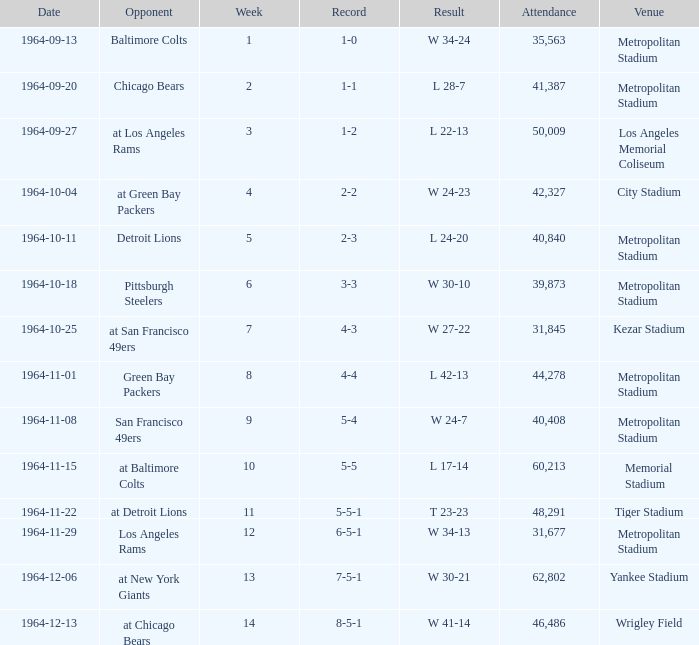Could you help me parse every detail presented in this table? {'header': ['Date', 'Opponent', 'Week', 'Record', 'Result', 'Attendance', 'Venue'], 'rows': [['1964-09-13', 'Baltimore Colts', '1', '1-0', 'W 34-24', '35,563', 'Metropolitan Stadium'], ['1964-09-20', 'Chicago Bears', '2', '1-1', 'L 28-7', '41,387', 'Metropolitan Stadium'], ['1964-09-27', 'at Los Angeles Rams', '3', '1-2', 'L 22-13', '50,009', 'Los Angeles Memorial Coliseum'], ['1964-10-04', 'at Green Bay Packers', '4', '2-2', 'W 24-23', '42,327', 'City Stadium'], ['1964-10-11', 'Detroit Lions', '5', '2-3', 'L 24-20', '40,840', 'Metropolitan Stadium'], ['1964-10-18', 'Pittsburgh Steelers', '6', '3-3', 'W 30-10', '39,873', 'Metropolitan Stadium'], ['1964-10-25', 'at San Francisco 49ers', '7', '4-3', 'W 27-22', '31,845', 'Kezar Stadium'], ['1964-11-01', 'Green Bay Packers', '8', '4-4', 'L 42-13', '44,278', 'Metropolitan Stadium'], ['1964-11-08', 'San Francisco 49ers', '9', '5-4', 'W 24-7', '40,408', 'Metropolitan Stadium'], ['1964-11-15', 'at Baltimore Colts', '10', '5-5', 'L 17-14', '60,213', 'Memorial Stadium'], ['1964-11-22', 'at Detroit Lions', '11', '5-5-1', 'T 23-23', '48,291', 'Tiger Stadium'], ['1964-11-29', 'Los Angeles Rams', '12', '6-5-1', 'W 34-13', '31,677', 'Metropolitan Stadium'], ['1964-12-06', 'at New York Giants', '13', '7-5-1', 'W 30-21', '62,802', 'Yankee Stadium'], ['1964-12-13', 'at Chicago Bears', '14', '8-5-1', 'W 41-14', '46,486', 'Wrigley Field']]} What is the result when the record was 1-0 and it was earlier than week 4? W 34-24. 